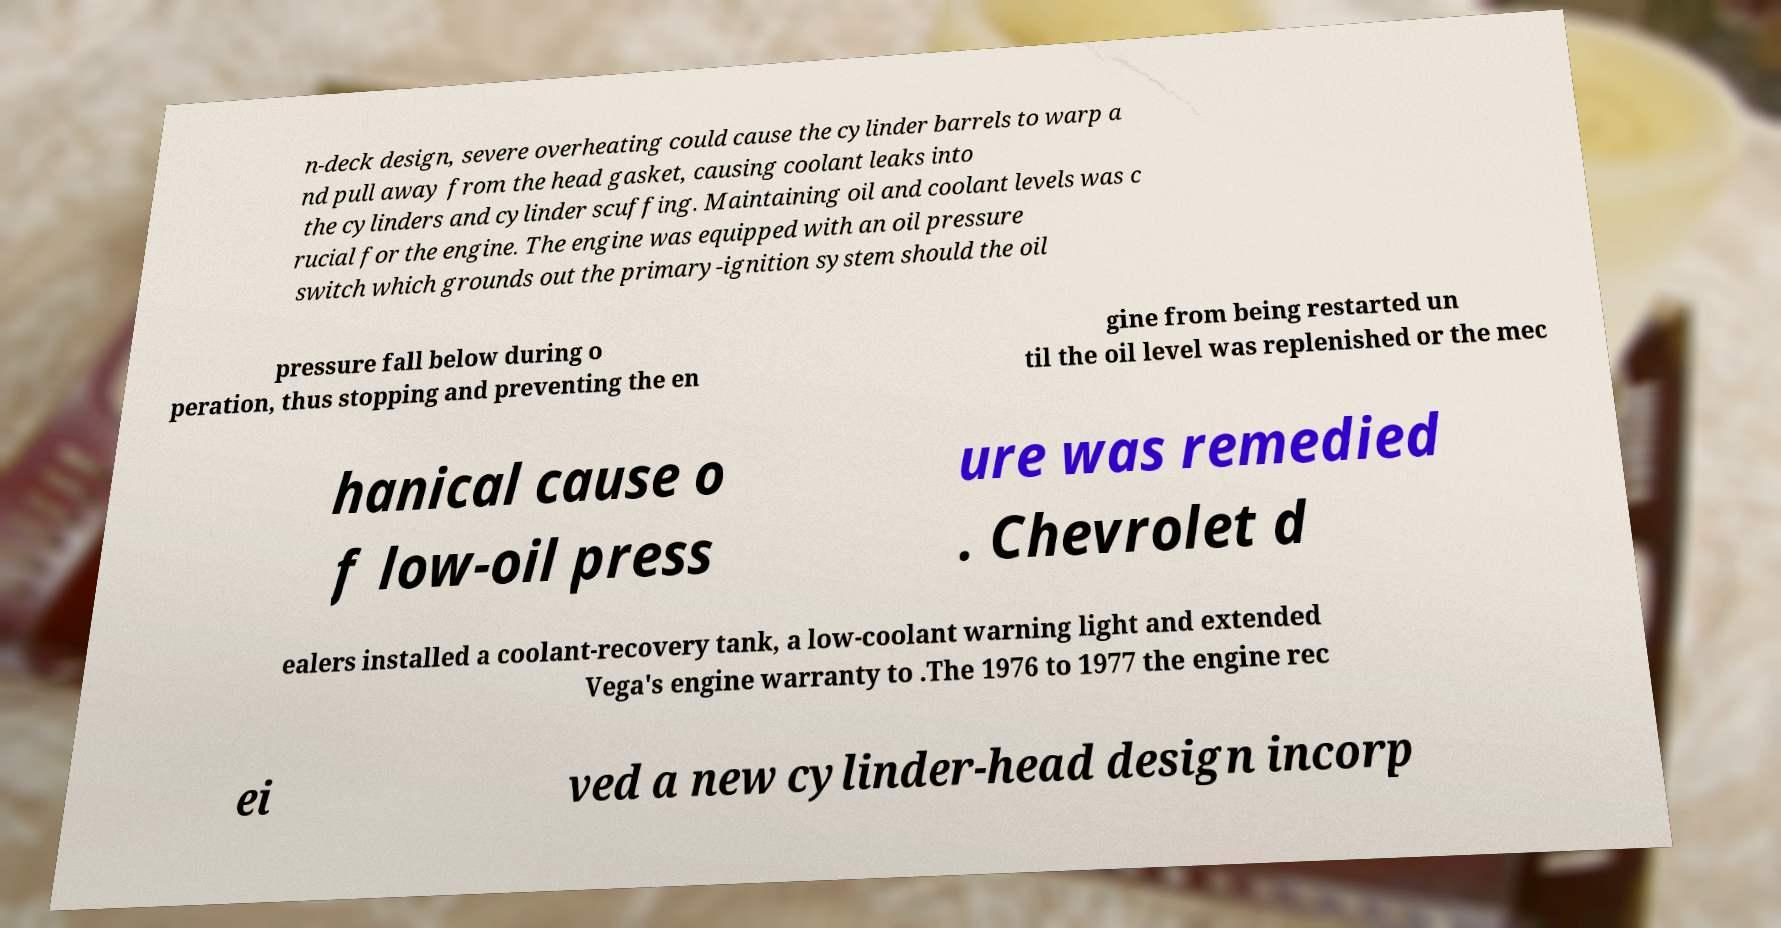There's text embedded in this image that I need extracted. Can you transcribe it verbatim? n-deck design, severe overheating could cause the cylinder barrels to warp a nd pull away from the head gasket, causing coolant leaks into the cylinders and cylinder scuffing. Maintaining oil and coolant levels was c rucial for the engine. The engine was equipped with an oil pressure switch which grounds out the primary-ignition system should the oil pressure fall below during o peration, thus stopping and preventing the en gine from being restarted un til the oil level was replenished or the mec hanical cause o f low-oil press ure was remedied . Chevrolet d ealers installed a coolant-recovery tank, a low-coolant warning light and extended Vega's engine warranty to .The 1976 to 1977 the engine rec ei ved a new cylinder-head design incorp 